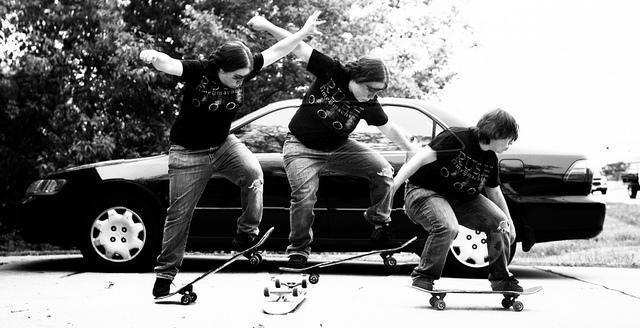How many skateboards are in the picture?
Give a very brief answer. 3. How many people are in the picture?
Give a very brief answer. 3. How many baby elephants are there?
Give a very brief answer. 0. 